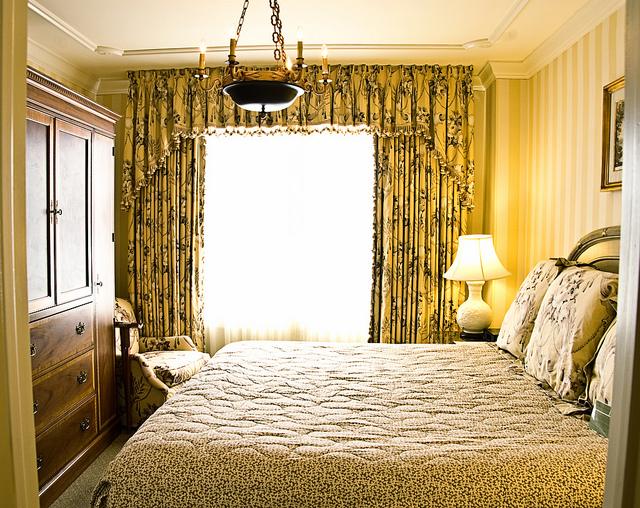Is the bed neatly made?
Be succinct. Yes. Is the lamp turned on?
Write a very short answer. Yes. What color is the chair?
Concise answer only. White. Is there a canopy on the bed?
Answer briefly. No. Is there a chandelier in the room?
Write a very short answer. Yes. 